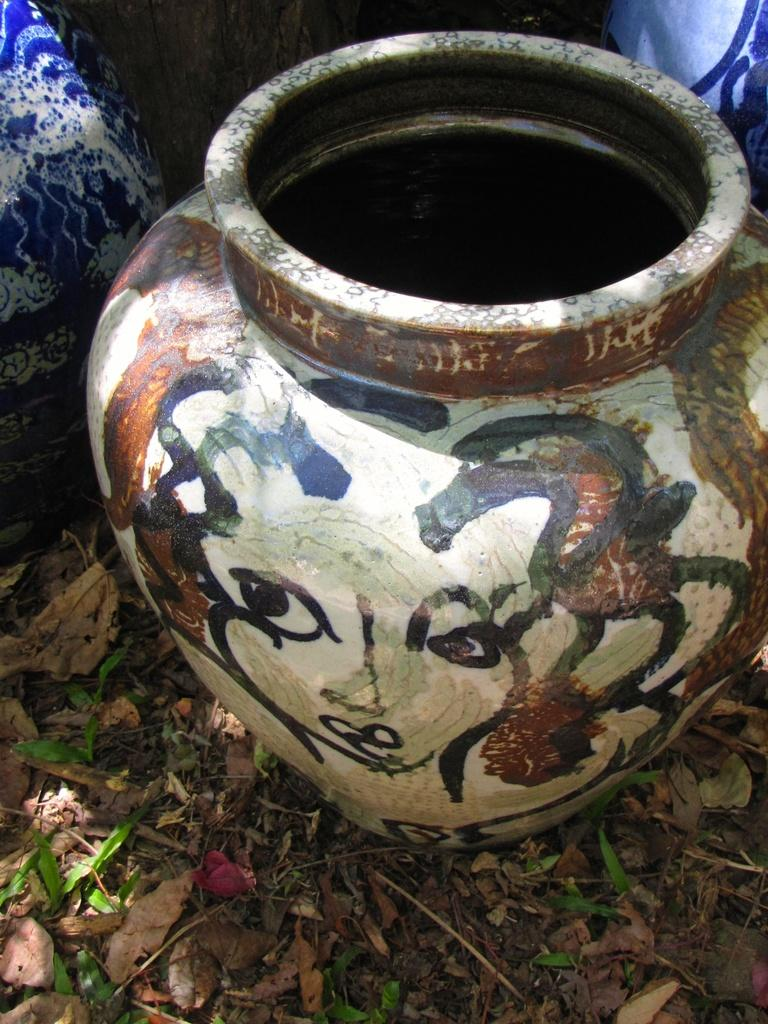What object can be seen in the image? There is a vase in the image. What else is visible at the bottom of the image? There are leaves at the bottom of the image. Is there a beggar asking for money in the image? No, there is no beggar present in the image. Can you see a man walking in the image? No, there is no man walking in the image. 